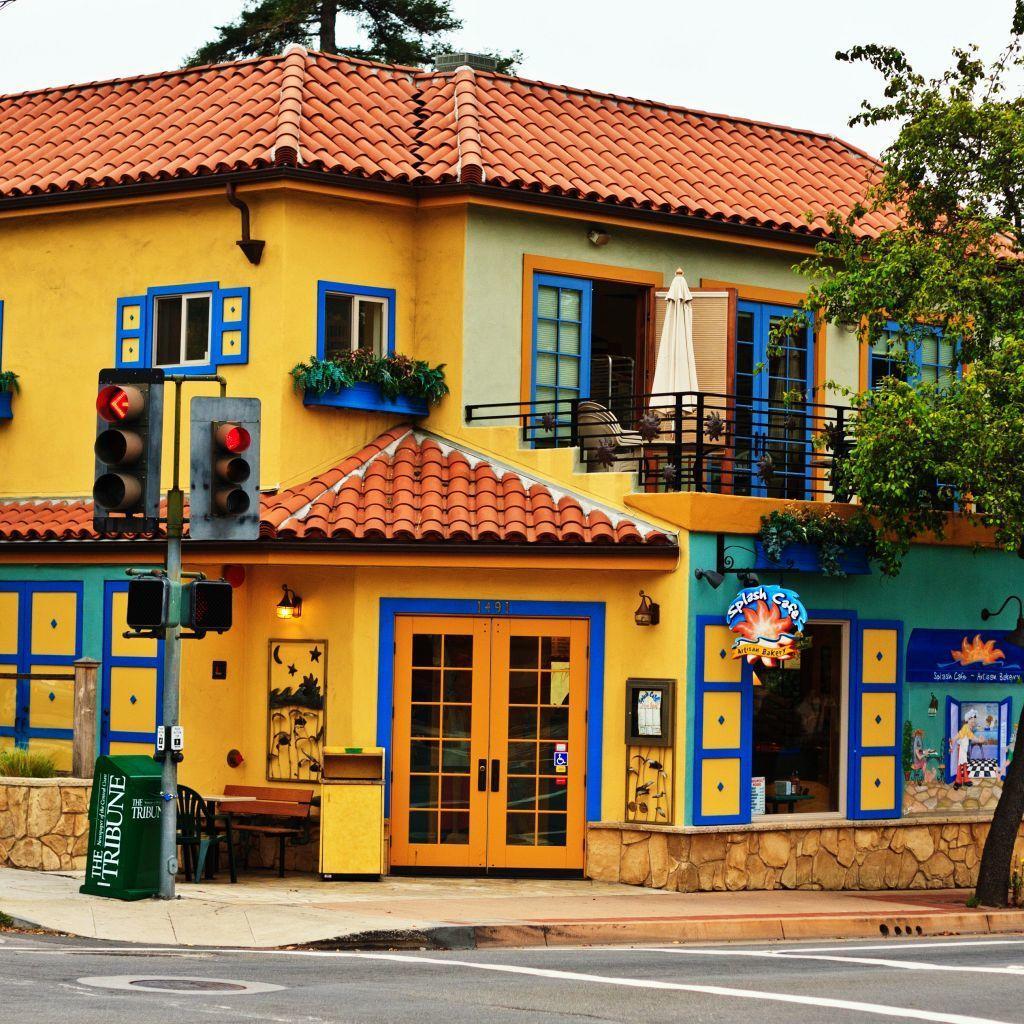Could you give a brief overview of what you see in this image? In the foreground of this picture, there is a road. In the background, there is a building, door, traffic signal pole, umbrella, chairs, plants, trees, railing and the sky. 